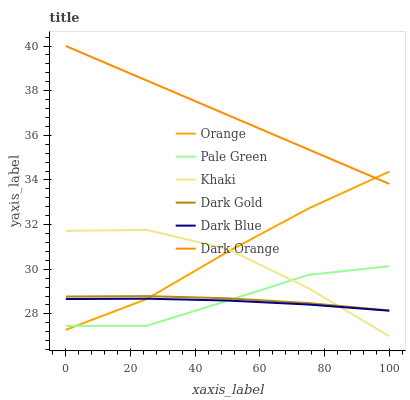Does Khaki have the minimum area under the curve?
Answer yes or no. No. Does Khaki have the maximum area under the curve?
Answer yes or no. No. Is Dark Gold the smoothest?
Answer yes or no. No. Is Dark Gold the roughest?
Answer yes or no. No. Does Dark Gold have the lowest value?
Answer yes or no. No. Does Khaki have the highest value?
Answer yes or no. No. Is Khaki less than Dark Orange?
Answer yes or no. Yes. Is Dark Orange greater than Dark Gold?
Answer yes or no. Yes. Does Khaki intersect Dark Orange?
Answer yes or no. No. 